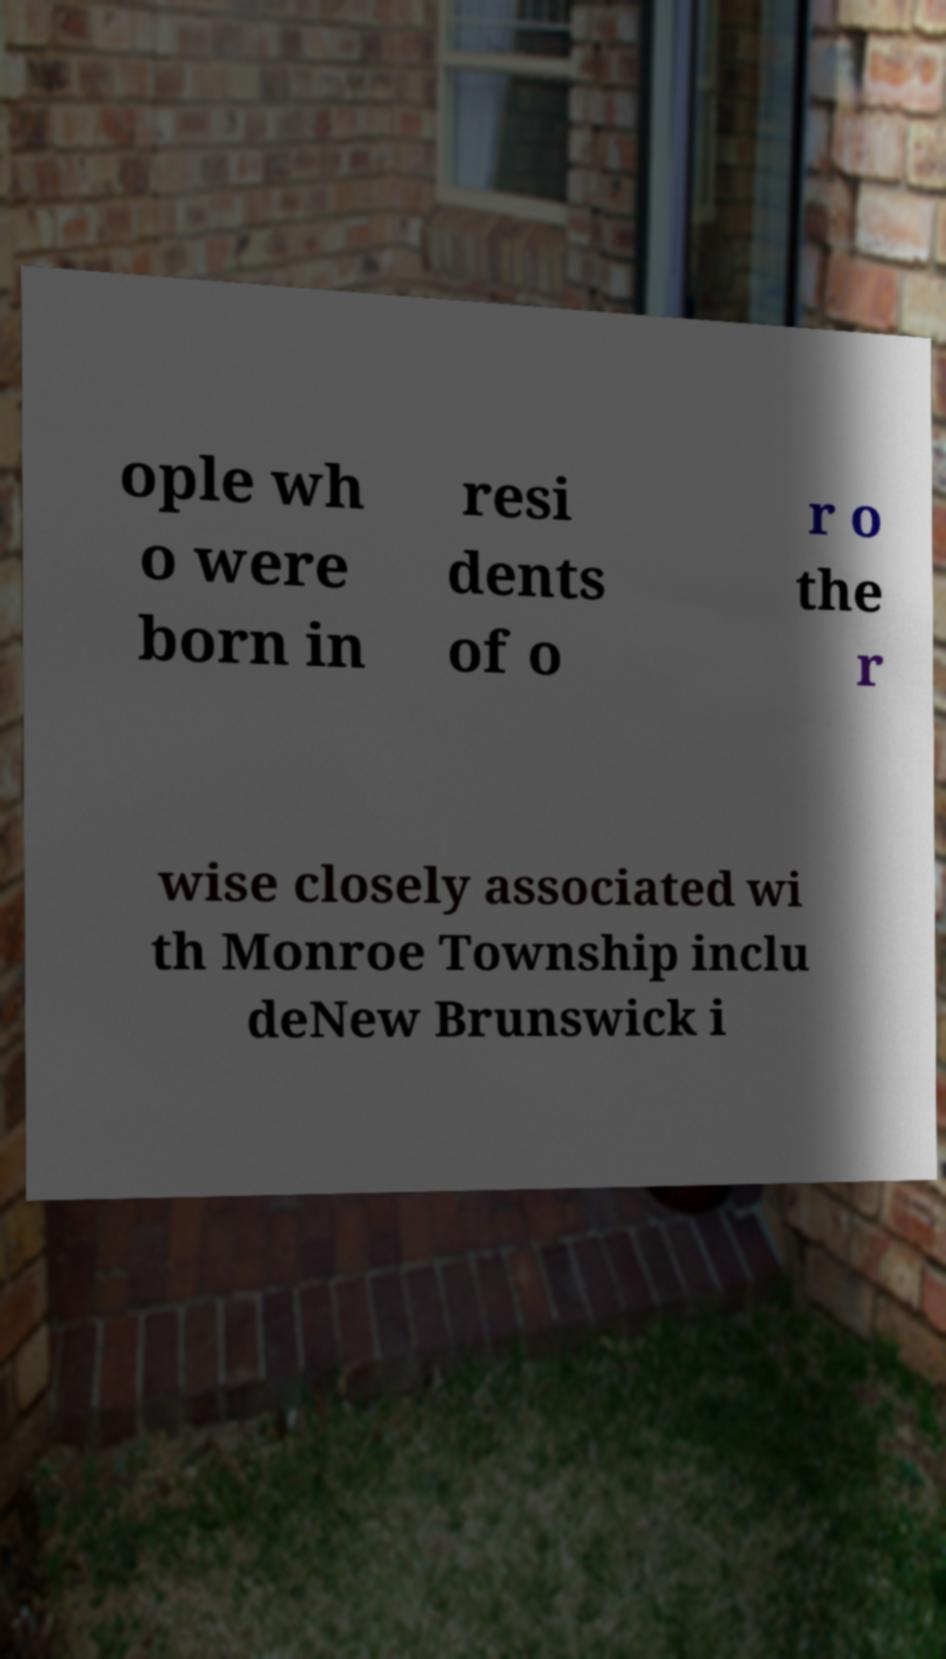Can you accurately transcribe the text from the provided image for me? ople wh o were born in resi dents of o r o the r wise closely associated wi th Monroe Township inclu deNew Brunswick i 